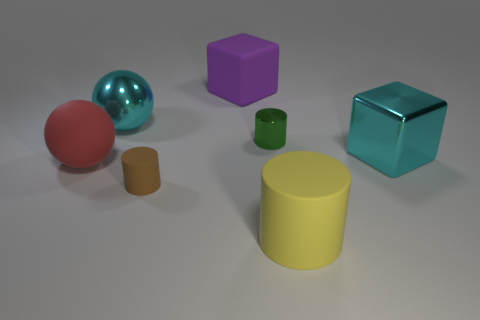Add 1 big yellow objects. How many objects exist? 8 Subtract all cylinders. How many objects are left? 4 Subtract 0 cyan cylinders. How many objects are left? 7 Subtract all shiny cylinders. Subtract all tiny green objects. How many objects are left? 5 Add 2 small metallic cylinders. How many small metallic cylinders are left? 3 Add 7 small rubber objects. How many small rubber objects exist? 8 